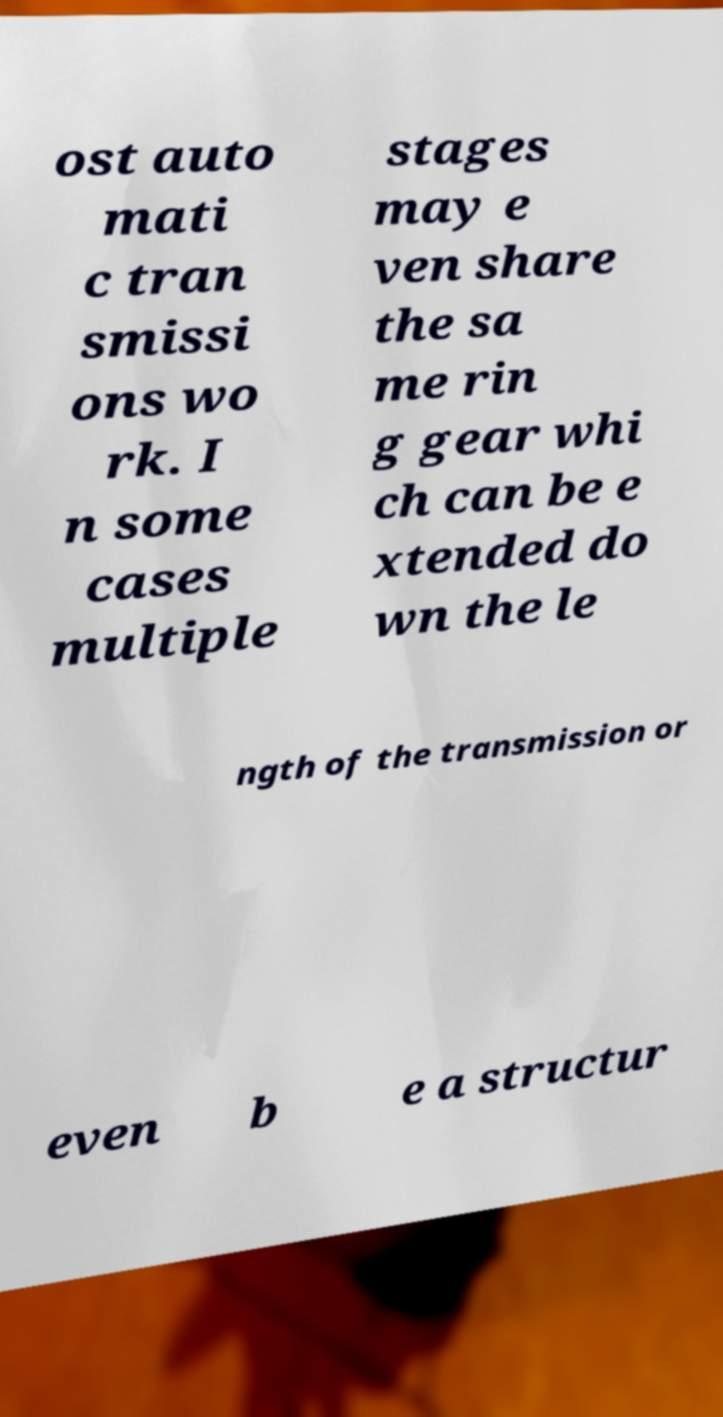I need the written content from this picture converted into text. Can you do that? ost auto mati c tran smissi ons wo rk. I n some cases multiple stages may e ven share the sa me rin g gear whi ch can be e xtended do wn the le ngth of the transmission or even b e a structur 